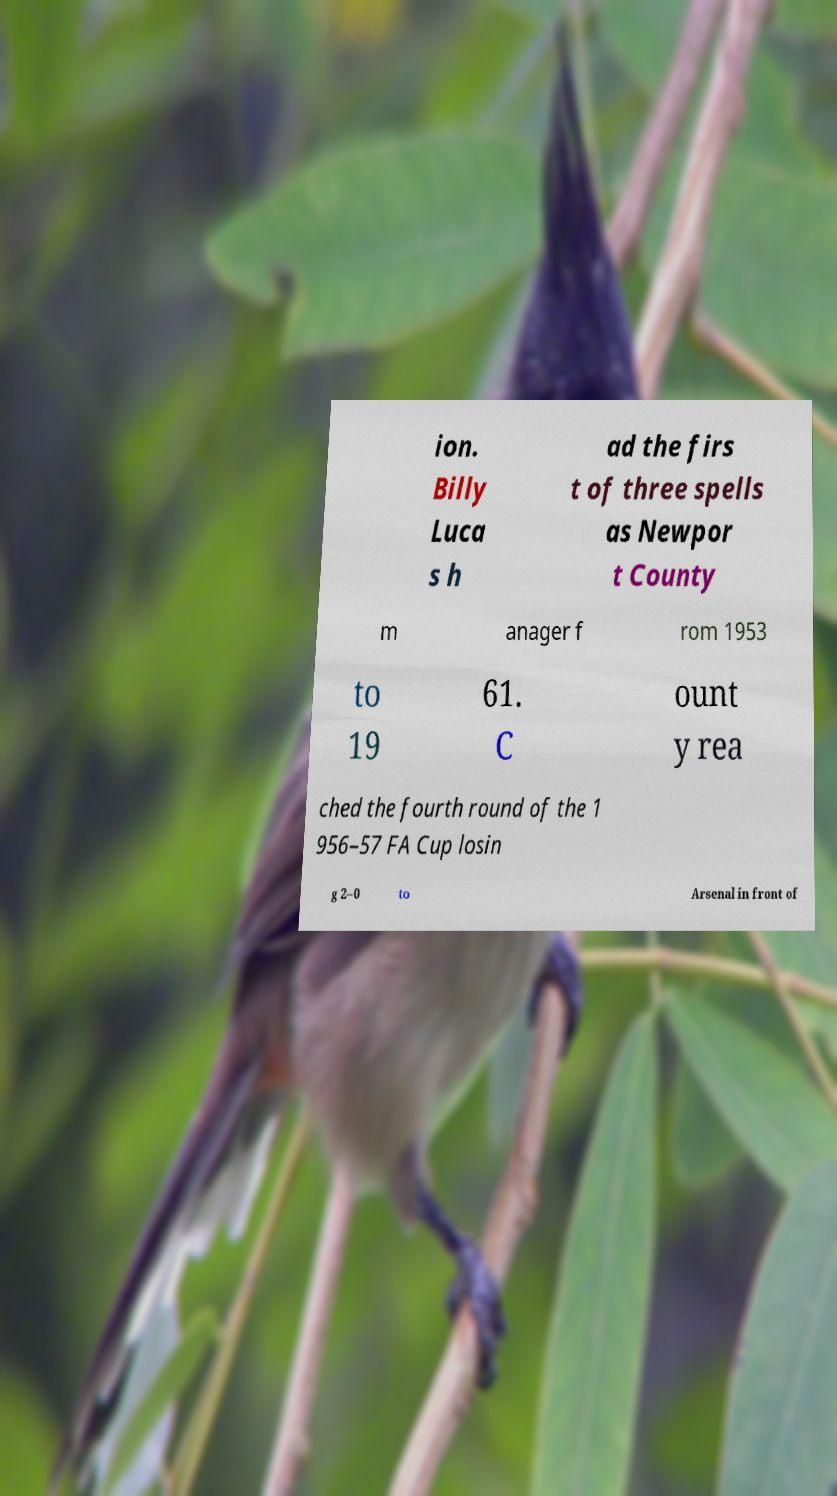For documentation purposes, I need the text within this image transcribed. Could you provide that? ion. Billy Luca s h ad the firs t of three spells as Newpor t County m anager f rom 1953 to 19 61. C ount y rea ched the fourth round of the 1 956–57 FA Cup losin g 2–0 to Arsenal in front of 